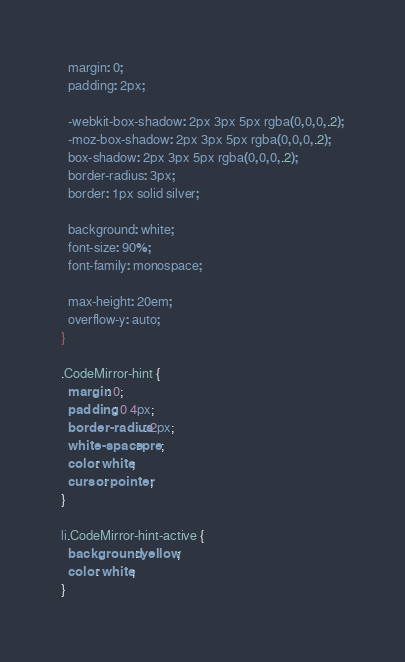<code> <loc_0><loc_0><loc_500><loc_500><_CSS_>  margin: 0;
  padding: 2px;

  -webkit-box-shadow: 2px 3px 5px rgba(0,0,0,.2);
  -moz-box-shadow: 2px 3px 5px rgba(0,0,0,.2);
  box-shadow: 2px 3px 5px rgba(0,0,0,.2);
  border-radius: 3px;
  border: 1px solid silver;

  background: white;
  font-size: 90%;
  font-family: monospace;

  max-height: 20em;
  overflow-y: auto;
}

.CodeMirror-hint {
  margin: 0;
  padding: 0 4px;
  border-radius: 2px;
  white-space: pre;
  color: white;
  cursor: pointer;
}

li.CodeMirror-hint-active {
  background: yellow;
  color: white;
}
</code> 